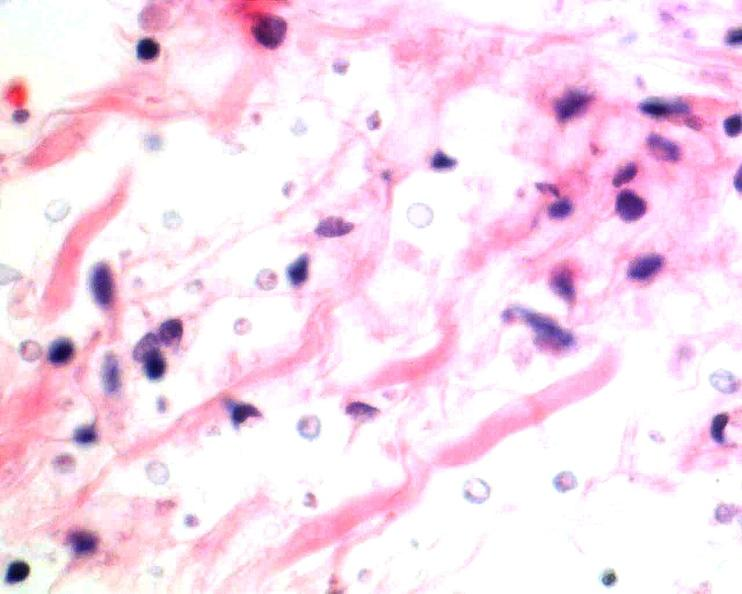what is present?
Answer the question using a single word or phrase. Nervous 